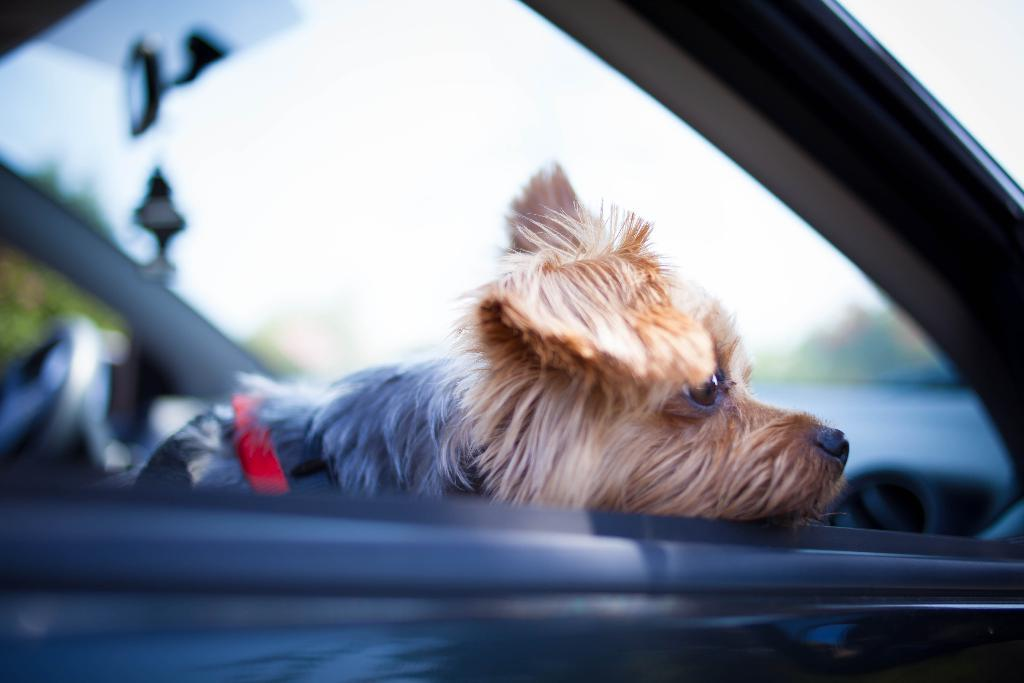What type of animal is in the image? There is a small puppy in the image. What other object can be seen in the image? There appears to be a car in the image. Can you confirm the presence of a steering wheel in the image? No, it is not clear enough to confirm the presence of a steering wheel in the image. What type of border is visible in the image? There is no border visible in the image. How does the sun appear in the image? The image does not show the sun; it is not present. 